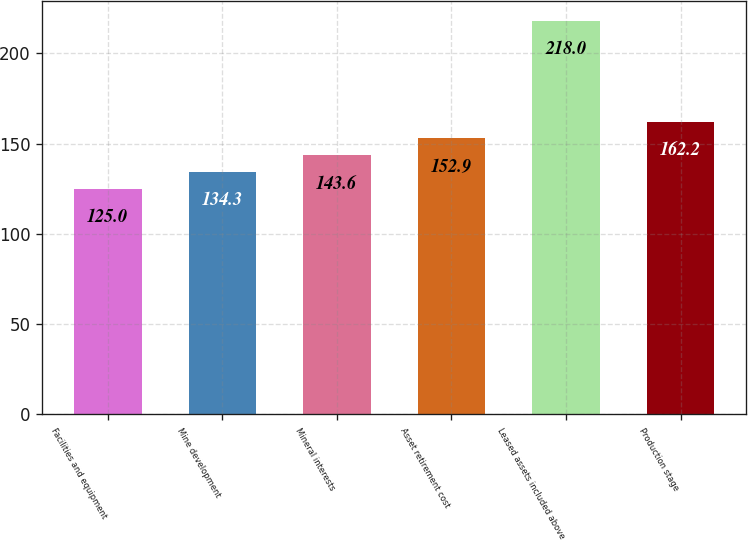<chart> <loc_0><loc_0><loc_500><loc_500><bar_chart><fcel>Facilities and equipment<fcel>Mine development<fcel>Mineral interests<fcel>Asset retirement cost<fcel>Leased assets included above<fcel>Production stage<nl><fcel>125<fcel>134.3<fcel>143.6<fcel>152.9<fcel>218<fcel>162.2<nl></chart> 